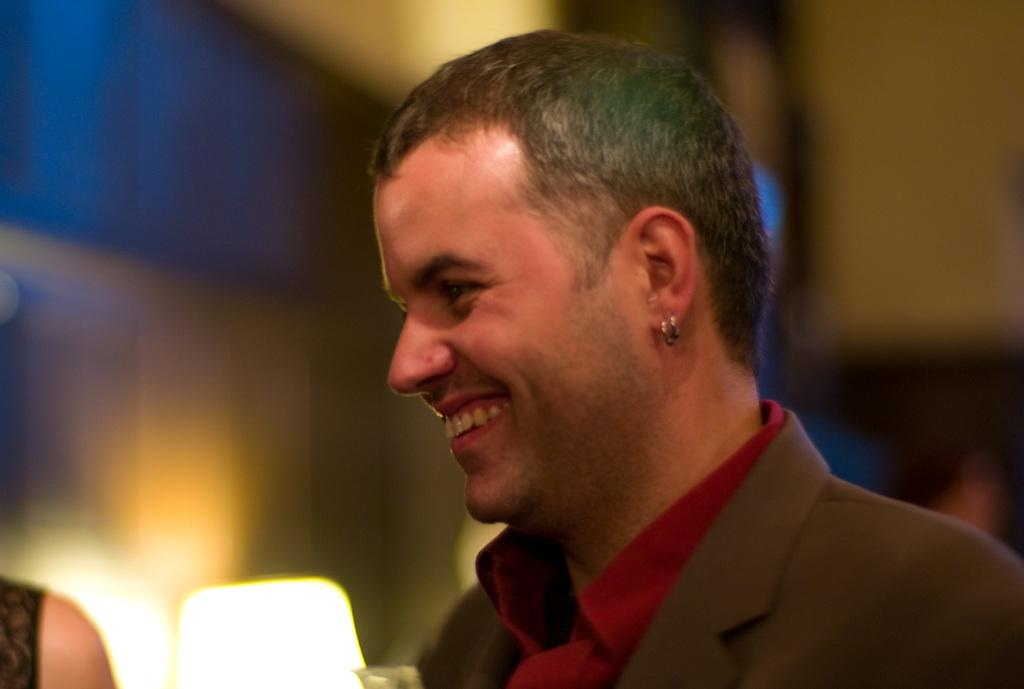Who is the main subject in the foreground of the picture? There is a person in the foreground of the picture. What is the person doing in the image? The person is smiling. What object is located in the center of the image? There is a lamp in the center of the image. Can you describe the person on the left side of the image? A person's shoulder is visible on the left side of the image. How would you describe the background of the image? The background of the image is blurred. What type of weather can be seen in the image? There is no indication of weather in the image, as it is focused on the person and the lamp. How many spiders are crawling on the person's shoulder in the image? There are no spiders visible on the person's shoulder in the image. 